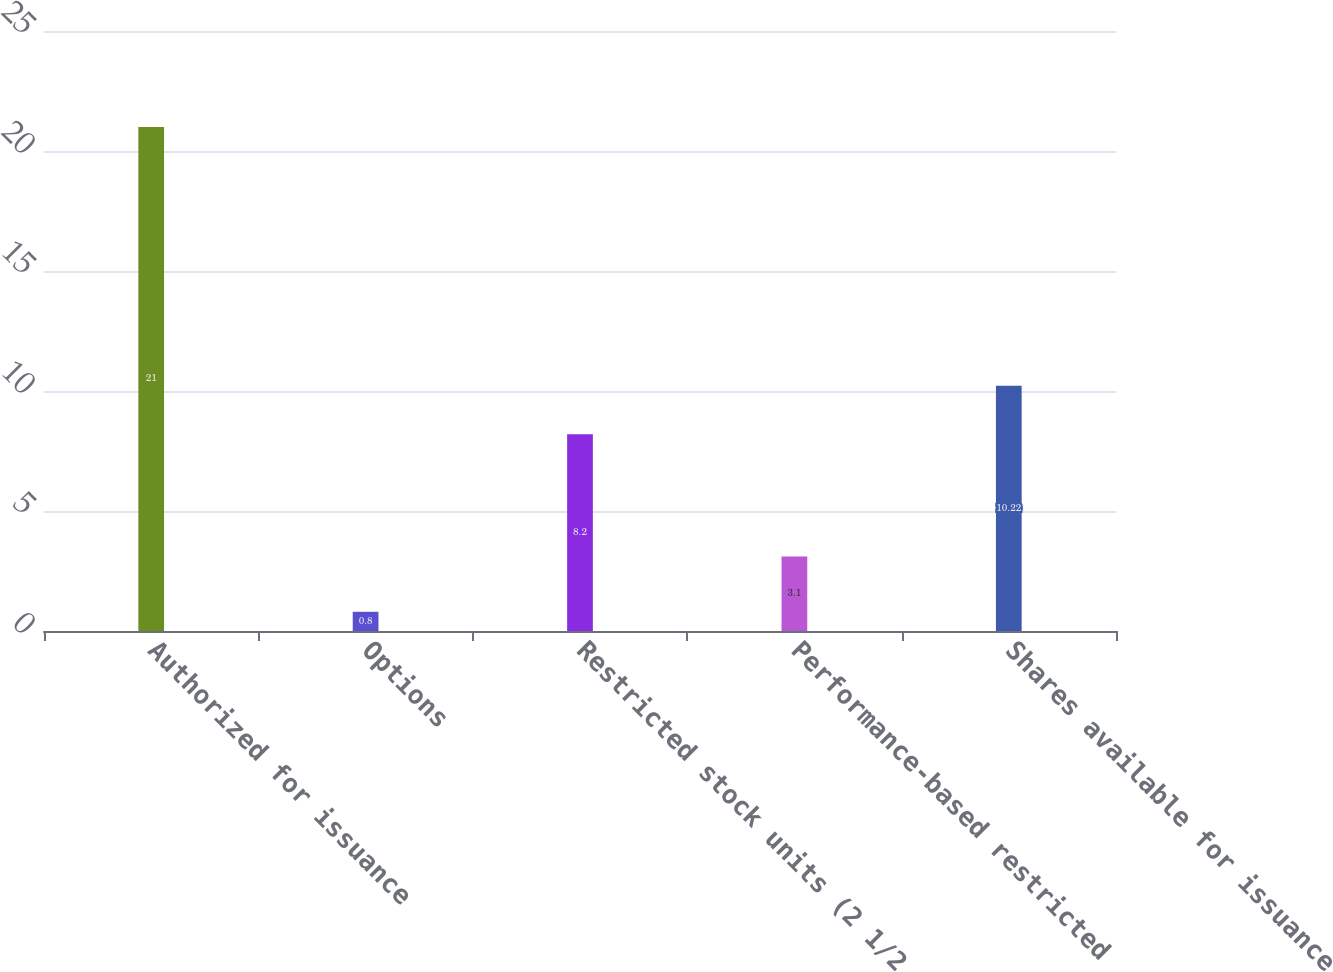<chart> <loc_0><loc_0><loc_500><loc_500><bar_chart><fcel>Authorized for issuance<fcel>Options<fcel>Restricted stock units (2 1/2<fcel>Performance-based restricted<fcel>Shares available for issuance<nl><fcel>21<fcel>0.8<fcel>8.2<fcel>3.1<fcel>10.22<nl></chart> 